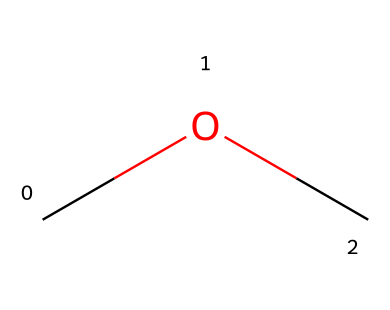What is the molecular formula of this compound? The molecular formula is derived from counting each type of atom in the structure. There are two carbon (C) atoms and six hydrogen (H) atoms, leading to the formula C2H6O.
Answer: C2H6O How many hydrogen atoms are present in dimethyl ether? By examining the structure, you can count the hydrogen atoms bonded to the carbon atoms. There are a total of six hydrogen atoms.
Answer: 6 What type of functional group does dimethyl ether contain? The presence of an oxygen atom bonded to two carbon atoms indicates that this compound features an ether functional group, characterized by the R-O-R' structure.
Answer: ether Is dimethyl ether a gas, liquid, or solid at room temperature? Dimethyl ether has a low boiling point of about -24 degrees Celsius, which means it exists as a gas under standard conditions, as it will have not condensed into a liquid at room temperature.
Answer: gas What is the significance of the number of carbon atoms in dimethyl ether? The presence of two carbon atoms indicates that dimethyl ether is the simplest ether, influencing its physical and chemical properties, including its volatility and applications.
Answer: simplest ether What kind of interaction does the oxygen atom facilitate in ethers? The oxygen atom in ethers can engage in hydrogen bonding with water or other polar molecules, affecting solubility and reactivity, but here it is limited by the lack of hydrogen atoms bonded directly to it.
Answer: hydrogen bonding What applications does dimethyl ether have in industry? Dimethyl ether is commonly used as an aerosol propellant due to its favorable vapor pressure and non-flammability, making it a safer alternative in formulation compared to hydrocarbons.
Answer: aerosol propellant 